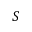<formula> <loc_0><loc_0><loc_500><loc_500>S</formula> 